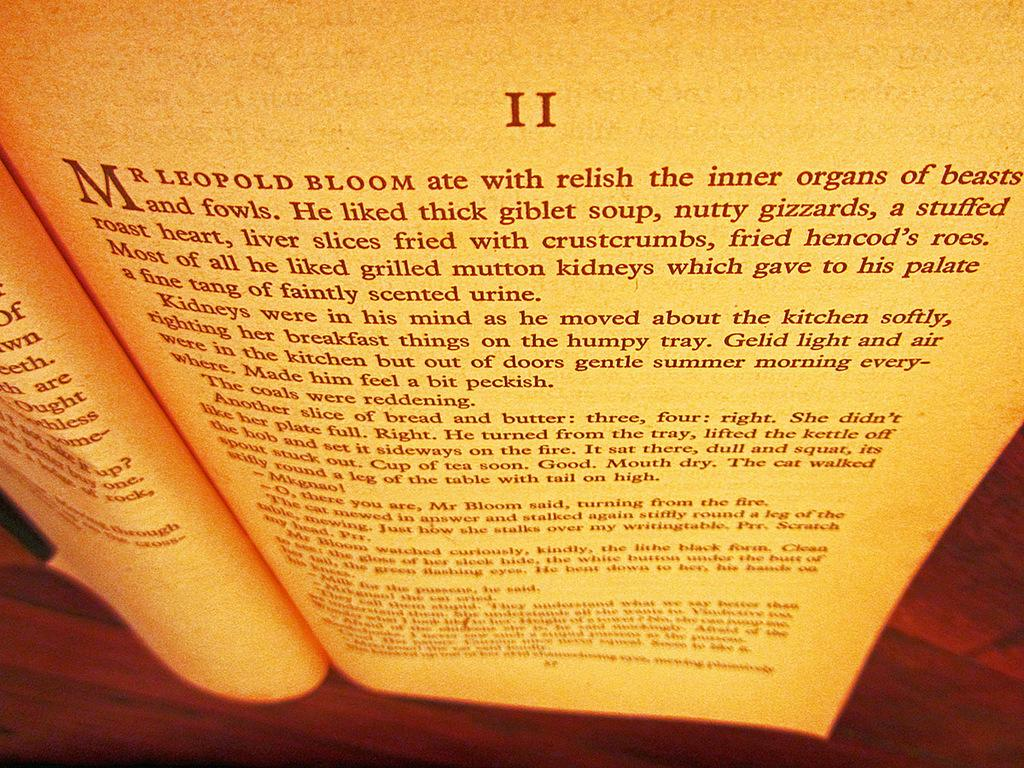<image>
Provide a brief description of the given image. Chapter II of a book is opened to a page that begins Mr. Leopold. 